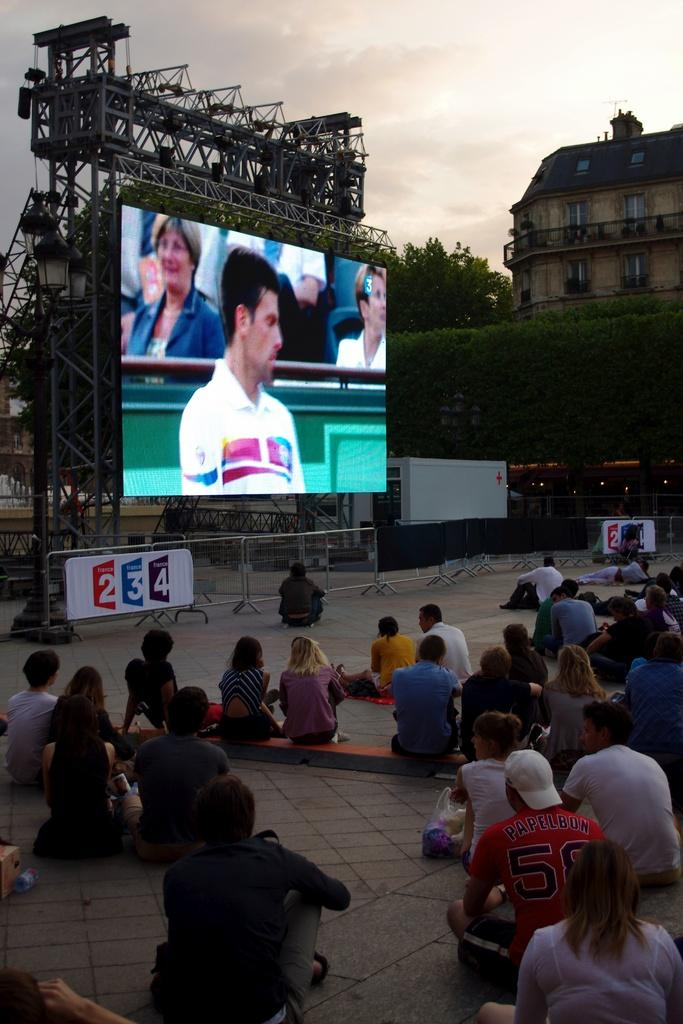<image>
Provide a brief description of the given image. A large screen with a banner underneath that says france 2, 3 and 4 